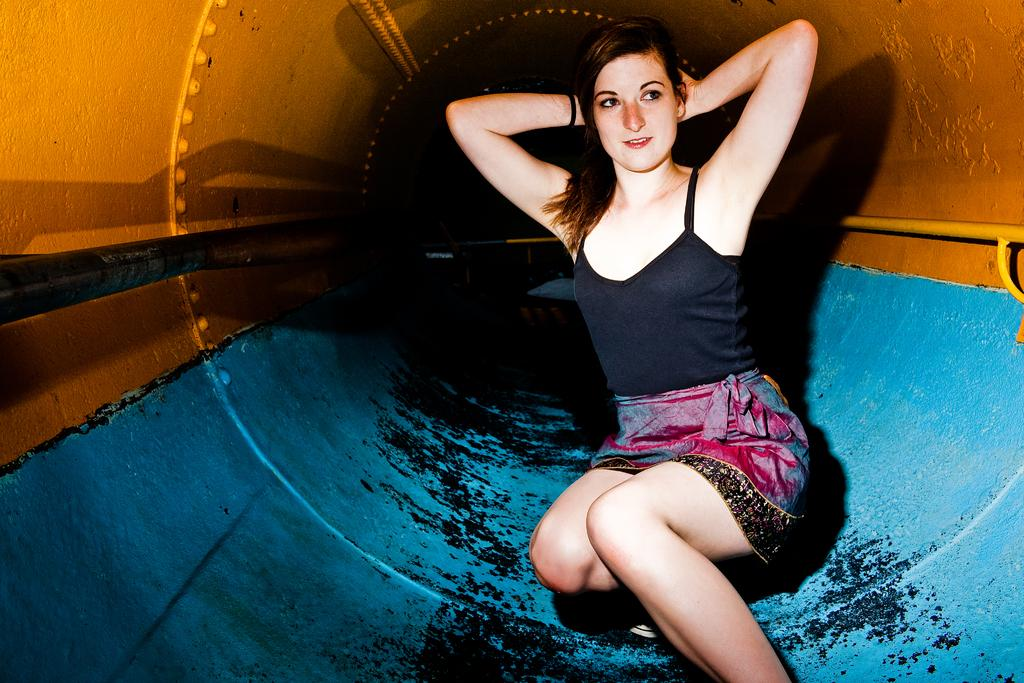Who is the main subject in the image? There is a woman in the image. What is the woman wearing on her upper body? The woman is wearing a black top. What type of clothing is the woman wearing on her lower body? The woman is wearing a skirt. What can be seen in the background of the image? There is a metal tunnel in the background of the image. What type of pail is the woman using to rub the comparison in the image? There is no pail or comparison present in the image. 